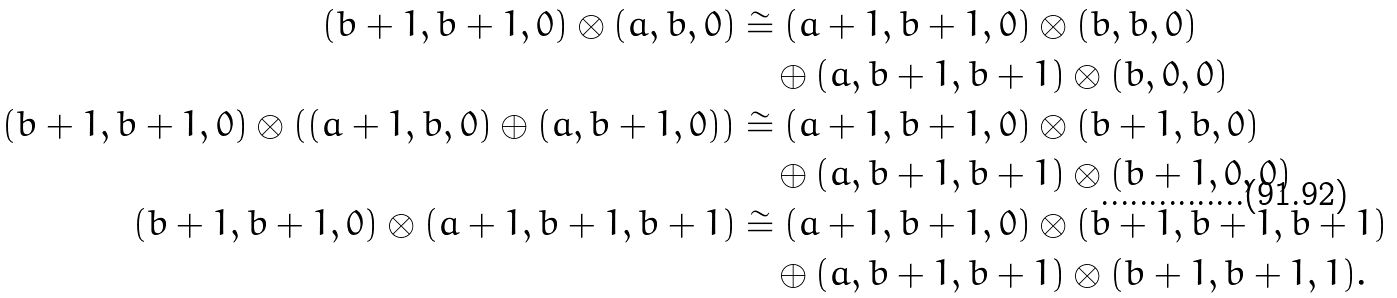Convert formula to latex. <formula><loc_0><loc_0><loc_500><loc_500>( b + 1 , b + 1 , 0 ) \otimes ( a , b , 0 ) & \cong ( a + 1 , b + 1 , 0 ) \otimes ( b , b , 0 ) \\ & \quad \oplus ( a , b + 1 , b + 1 ) \otimes ( b , 0 , 0 ) \\ ( b + 1 , b + 1 , 0 ) \otimes ( ( a + 1 , b , 0 ) \oplus ( a , b + 1 , 0 ) ) & \cong ( a + 1 , b + 1 , 0 ) \otimes ( b + 1 , b , 0 ) \\ & \quad \oplus ( a , b + 1 , b + 1 ) \otimes ( b + 1 , 0 , 0 ) \\ ( b + 1 , b + 1 , 0 ) \otimes ( a + 1 , b + 1 , b + 1 ) & \cong ( a + 1 , b + 1 , 0 ) \otimes ( b + 1 , b + 1 , b + 1 ) \\ & \quad \oplus ( a , b + 1 , b + 1 ) \otimes ( b + 1 , b + 1 , 1 ) .</formula> 